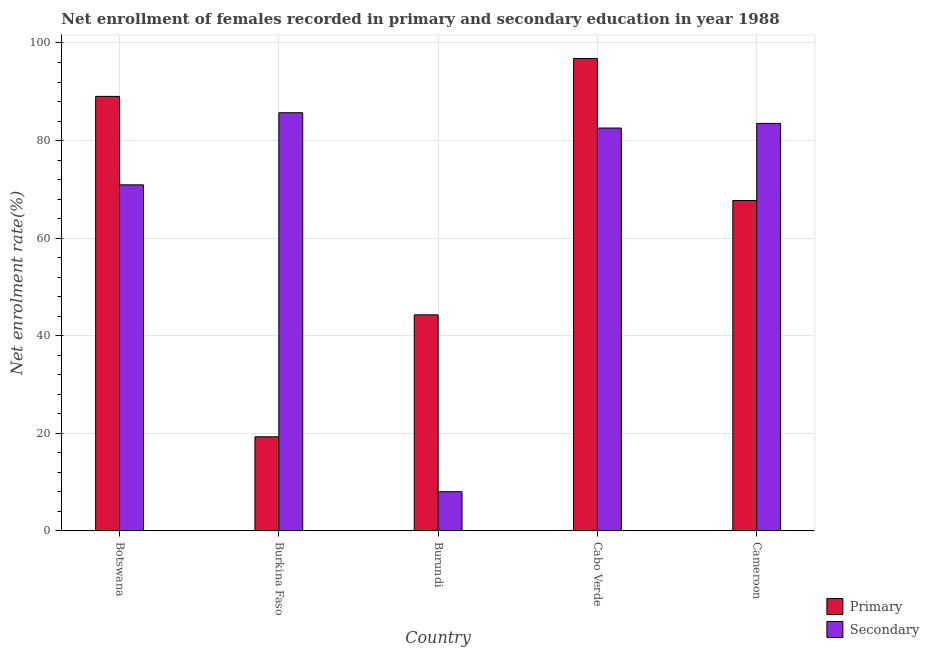How many groups of bars are there?
Provide a short and direct response. 5. Are the number of bars on each tick of the X-axis equal?
Your answer should be very brief. Yes. How many bars are there on the 3rd tick from the left?
Make the answer very short. 2. What is the label of the 4th group of bars from the left?
Offer a terse response. Cabo Verde. In how many cases, is the number of bars for a given country not equal to the number of legend labels?
Keep it short and to the point. 0. What is the enrollment rate in primary education in Cameroon?
Your answer should be compact. 67.71. Across all countries, what is the maximum enrollment rate in secondary education?
Your answer should be very brief. 85.71. Across all countries, what is the minimum enrollment rate in secondary education?
Offer a very short reply. 8.04. In which country was the enrollment rate in primary education maximum?
Offer a terse response. Cabo Verde. In which country was the enrollment rate in secondary education minimum?
Offer a very short reply. Burundi. What is the total enrollment rate in secondary education in the graph?
Your answer should be very brief. 330.78. What is the difference between the enrollment rate in primary education in Botswana and that in Burkina Faso?
Give a very brief answer. 69.77. What is the difference between the enrollment rate in secondary education in Burkina Faso and the enrollment rate in primary education in Burundi?
Offer a terse response. 41.42. What is the average enrollment rate in secondary education per country?
Your response must be concise. 66.16. What is the difference between the enrollment rate in primary education and enrollment rate in secondary education in Burkina Faso?
Keep it short and to the point. -66.42. In how many countries, is the enrollment rate in secondary education greater than 64 %?
Provide a short and direct response. 4. What is the ratio of the enrollment rate in primary education in Cabo Verde to that in Cameroon?
Your response must be concise. 1.43. Is the enrollment rate in secondary education in Botswana less than that in Cameroon?
Make the answer very short. Yes. What is the difference between the highest and the second highest enrollment rate in secondary education?
Make the answer very short. 2.19. What is the difference between the highest and the lowest enrollment rate in primary education?
Provide a short and direct response. 77.53. In how many countries, is the enrollment rate in primary education greater than the average enrollment rate in primary education taken over all countries?
Offer a very short reply. 3. Is the sum of the enrollment rate in secondary education in Burkina Faso and Burundi greater than the maximum enrollment rate in primary education across all countries?
Your answer should be compact. No. What does the 1st bar from the left in Burkina Faso represents?
Provide a succinct answer. Primary. What does the 2nd bar from the right in Botswana represents?
Offer a very short reply. Primary. Are all the bars in the graph horizontal?
Make the answer very short. No. How many countries are there in the graph?
Give a very brief answer. 5. Where does the legend appear in the graph?
Offer a very short reply. Bottom right. How are the legend labels stacked?
Your answer should be very brief. Vertical. What is the title of the graph?
Offer a very short reply. Net enrollment of females recorded in primary and secondary education in year 1988. What is the label or title of the X-axis?
Keep it short and to the point. Country. What is the label or title of the Y-axis?
Offer a terse response. Net enrolment rate(%). What is the Net enrolment rate(%) in Primary in Botswana?
Your response must be concise. 89.06. What is the Net enrolment rate(%) of Secondary in Botswana?
Give a very brief answer. 70.93. What is the Net enrolment rate(%) in Primary in Burkina Faso?
Ensure brevity in your answer.  19.29. What is the Net enrolment rate(%) in Secondary in Burkina Faso?
Your answer should be compact. 85.71. What is the Net enrolment rate(%) of Primary in Burundi?
Ensure brevity in your answer.  44.29. What is the Net enrolment rate(%) in Secondary in Burundi?
Offer a very short reply. 8.04. What is the Net enrolment rate(%) of Primary in Cabo Verde?
Make the answer very short. 96.82. What is the Net enrolment rate(%) in Secondary in Cabo Verde?
Make the answer very short. 82.57. What is the Net enrolment rate(%) of Primary in Cameroon?
Offer a terse response. 67.71. What is the Net enrolment rate(%) in Secondary in Cameroon?
Offer a very short reply. 83.52. Across all countries, what is the maximum Net enrolment rate(%) in Primary?
Offer a terse response. 96.82. Across all countries, what is the maximum Net enrolment rate(%) of Secondary?
Your answer should be very brief. 85.71. Across all countries, what is the minimum Net enrolment rate(%) in Primary?
Keep it short and to the point. 19.29. Across all countries, what is the minimum Net enrolment rate(%) of Secondary?
Give a very brief answer. 8.04. What is the total Net enrolment rate(%) of Primary in the graph?
Make the answer very short. 317.17. What is the total Net enrolment rate(%) in Secondary in the graph?
Ensure brevity in your answer.  330.78. What is the difference between the Net enrolment rate(%) in Primary in Botswana and that in Burkina Faso?
Provide a succinct answer. 69.77. What is the difference between the Net enrolment rate(%) of Secondary in Botswana and that in Burkina Faso?
Give a very brief answer. -14.78. What is the difference between the Net enrolment rate(%) of Primary in Botswana and that in Burundi?
Provide a short and direct response. 44.77. What is the difference between the Net enrolment rate(%) of Secondary in Botswana and that in Burundi?
Offer a terse response. 62.89. What is the difference between the Net enrolment rate(%) of Primary in Botswana and that in Cabo Verde?
Offer a terse response. -7.77. What is the difference between the Net enrolment rate(%) in Secondary in Botswana and that in Cabo Verde?
Offer a very short reply. -11.64. What is the difference between the Net enrolment rate(%) of Primary in Botswana and that in Cameroon?
Your answer should be compact. 21.35. What is the difference between the Net enrolment rate(%) in Secondary in Botswana and that in Cameroon?
Provide a short and direct response. -12.58. What is the difference between the Net enrolment rate(%) in Primary in Burkina Faso and that in Burundi?
Offer a terse response. -25. What is the difference between the Net enrolment rate(%) of Secondary in Burkina Faso and that in Burundi?
Provide a succinct answer. 77.67. What is the difference between the Net enrolment rate(%) in Primary in Burkina Faso and that in Cabo Verde?
Give a very brief answer. -77.53. What is the difference between the Net enrolment rate(%) in Secondary in Burkina Faso and that in Cabo Verde?
Ensure brevity in your answer.  3.14. What is the difference between the Net enrolment rate(%) in Primary in Burkina Faso and that in Cameroon?
Provide a succinct answer. -48.42. What is the difference between the Net enrolment rate(%) in Secondary in Burkina Faso and that in Cameroon?
Make the answer very short. 2.19. What is the difference between the Net enrolment rate(%) in Primary in Burundi and that in Cabo Verde?
Your answer should be compact. -52.53. What is the difference between the Net enrolment rate(%) of Secondary in Burundi and that in Cabo Verde?
Ensure brevity in your answer.  -74.53. What is the difference between the Net enrolment rate(%) of Primary in Burundi and that in Cameroon?
Offer a terse response. -23.42. What is the difference between the Net enrolment rate(%) of Secondary in Burundi and that in Cameroon?
Provide a short and direct response. -75.47. What is the difference between the Net enrolment rate(%) of Primary in Cabo Verde and that in Cameroon?
Make the answer very short. 29.11. What is the difference between the Net enrolment rate(%) of Secondary in Cabo Verde and that in Cameroon?
Make the answer very short. -0.94. What is the difference between the Net enrolment rate(%) in Primary in Botswana and the Net enrolment rate(%) in Secondary in Burkina Faso?
Your response must be concise. 3.35. What is the difference between the Net enrolment rate(%) in Primary in Botswana and the Net enrolment rate(%) in Secondary in Burundi?
Keep it short and to the point. 81.01. What is the difference between the Net enrolment rate(%) of Primary in Botswana and the Net enrolment rate(%) of Secondary in Cabo Verde?
Your response must be concise. 6.49. What is the difference between the Net enrolment rate(%) in Primary in Botswana and the Net enrolment rate(%) in Secondary in Cameroon?
Offer a very short reply. 5.54. What is the difference between the Net enrolment rate(%) in Primary in Burkina Faso and the Net enrolment rate(%) in Secondary in Burundi?
Provide a succinct answer. 11.25. What is the difference between the Net enrolment rate(%) of Primary in Burkina Faso and the Net enrolment rate(%) of Secondary in Cabo Verde?
Keep it short and to the point. -63.28. What is the difference between the Net enrolment rate(%) in Primary in Burkina Faso and the Net enrolment rate(%) in Secondary in Cameroon?
Ensure brevity in your answer.  -64.23. What is the difference between the Net enrolment rate(%) of Primary in Burundi and the Net enrolment rate(%) of Secondary in Cabo Verde?
Give a very brief answer. -38.28. What is the difference between the Net enrolment rate(%) of Primary in Burundi and the Net enrolment rate(%) of Secondary in Cameroon?
Offer a very short reply. -39.23. What is the difference between the Net enrolment rate(%) in Primary in Cabo Verde and the Net enrolment rate(%) in Secondary in Cameroon?
Your answer should be compact. 13.31. What is the average Net enrolment rate(%) of Primary per country?
Provide a short and direct response. 63.43. What is the average Net enrolment rate(%) in Secondary per country?
Offer a terse response. 66.16. What is the difference between the Net enrolment rate(%) of Primary and Net enrolment rate(%) of Secondary in Botswana?
Keep it short and to the point. 18.13. What is the difference between the Net enrolment rate(%) in Primary and Net enrolment rate(%) in Secondary in Burkina Faso?
Offer a very short reply. -66.42. What is the difference between the Net enrolment rate(%) of Primary and Net enrolment rate(%) of Secondary in Burundi?
Provide a succinct answer. 36.25. What is the difference between the Net enrolment rate(%) of Primary and Net enrolment rate(%) of Secondary in Cabo Verde?
Offer a very short reply. 14.25. What is the difference between the Net enrolment rate(%) in Primary and Net enrolment rate(%) in Secondary in Cameroon?
Make the answer very short. -15.81. What is the ratio of the Net enrolment rate(%) of Primary in Botswana to that in Burkina Faso?
Offer a terse response. 4.62. What is the ratio of the Net enrolment rate(%) in Secondary in Botswana to that in Burkina Faso?
Offer a very short reply. 0.83. What is the ratio of the Net enrolment rate(%) in Primary in Botswana to that in Burundi?
Your answer should be compact. 2.01. What is the ratio of the Net enrolment rate(%) in Secondary in Botswana to that in Burundi?
Your answer should be compact. 8.82. What is the ratio of the Net enrolment rate(%) in Primary in Botswana to that in Cabo Verde?
Provide a succinct answer. 0.92. What is the ratio of the Net enrolment rate(%) of Secondary in Botswana to that in Cabo Verde?
Provide a succinct answer. 0.86. What is the ratio of the Net enrolment rate(%) of Primary in Botswana to that in Cameroon?
Ensure brevity in your answer.  1.32. What is the ratio of the Net enrolment rate(%) in Secondary in Botswana to that in Cameroon?
Keep it short and to the point. 0.85. What is the ratio of the Net enrolment rate(%) of Primary in Burkina Faso to that in Burundi?
Provide a short and direct response. 0.44. What is the ratio of the Net enrolment rate(%) in Secondary in Burkina Faso to that in Burundi?
Ensure brevity in your answer.  10.66. What is the ratio of the Net enrolment rate(%) in Primary in Burkina Faso to that in Cabo Verde?
Offer a very short reply. 0.2. What is the ratio of the Net enrolment rate(%) in Secondary in Burkina Faso to that in Cabo Verde?
Offer a very short reply. 1.04. What is the ratio of the Net enrolment rate(%) in Primary in Burkina Faso to that in Cameroon?
Your response must be concise. 0.28. What is the ratio of the Net enrolment rate(%) in Secondary in Burkina Faso to that in Cameroon?
Provide a short and direct response. 1.03. What is the ratio of the Net enrolment rate(%) in Primary in Burundi to that in Cabo Verde?
Your response must be concise. 0.46. What is the ratio of the Net enrolment rate(%) of Secondary in Burundi to that in Cabo Verde?
Offer a very short reply. 0.1. What is the ratio of the Net enrolment rate(%) in Primary in Burundi to that in Cameroon?
Ensure brevity in your answer.  0.65. What is the ratio of the Net enrolment rate(%) in Secondary in Burundi to that in Cameroon?
Make the answer very short. 0.1. What is the ratio of the Net enrolment rate(%) in Primary in Cabo Verde to that in Cameroon?
Offer a terse response. 1.43. What is the ratio of the Net enrolment rate(%) in Secondary in Cabo Verde to that in Cameroon?
Provide a succinct answer. 0.99. What is the difference between the highest and the second highest Net enrolment rate(%) in Primary?
Make the answer very short. 7.77. What is the difference between the highest and the second highest Net enrolment rate(%) of Secondary?
Your answer should be compact. 2.19. What is the difference between the highest and the lowest Net enrolment rate(%) in Primary?
Offer a terse response. 77.53. What is the difference between the highest and the lowest Net enrolment rate(%) in Secondary?
Keep it short and to the point. 77.67. 